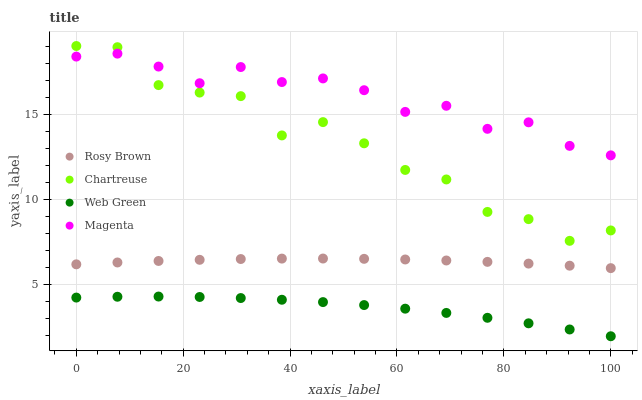Does Web Green have the minimum area under the curve?
Answer yes or no. Yes. Does Magenta have the maximum area under the curve?
Answer yes or no. Yes. Does Rosy Brown have the minimum area under the curve?
Answer yes or no. No. Does Rosy Brown have the maximum area under the curve?
Answer yes or no. No. Is Rosy Brown the smoothest?
Answer yes or no. Yes. Is Chartreuse the roughest?
Answer yes or no. Yes. Is Magenta the smoothest?
Answer yes or no. No. Is Magenta the roughest?
Answer yes or no. No. Does Web Green have the lowest value?
Answer yes or no. Yes. Does Rosy Brown have the lowest value?
Answer yes or no. No. Does Chartreuse have the highest value?
Answer yes or no. Yes. Does Rosy Brown have the highest value?
Answer yes or no. No. Is Web Green less than Magenta?
Answer yes or no. Yes. Is Rosy Brown greater than Web Green?
Answer yes or no. Yes. Does Magenta intersect Chartreuse?
Answer yes or no. Yes. Is Magenta less than Chartreuse?
Answer yes or no. No. Is Magenta greater than Chartreuse?
Answer yes or no. No. Does Web Green intersect Magenta?
Answer yes or no. No. 